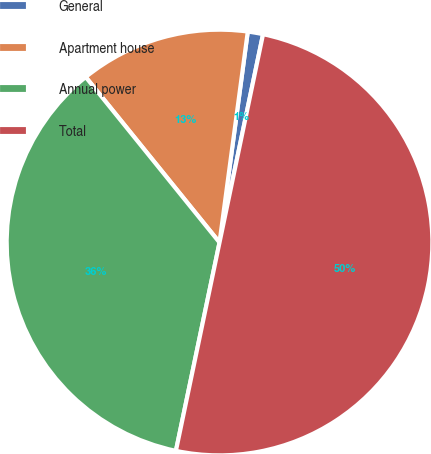<chart> <loc_0><loc_0><loc_500><loc_500><pie_chart><fcel>General<fcel>Apartment house<fcel>Annual power<fcel>Total<nl><fcel>1.16%<fcel>12.94%<fcel>35.89%<fcel>50.0%<nl></chart> 